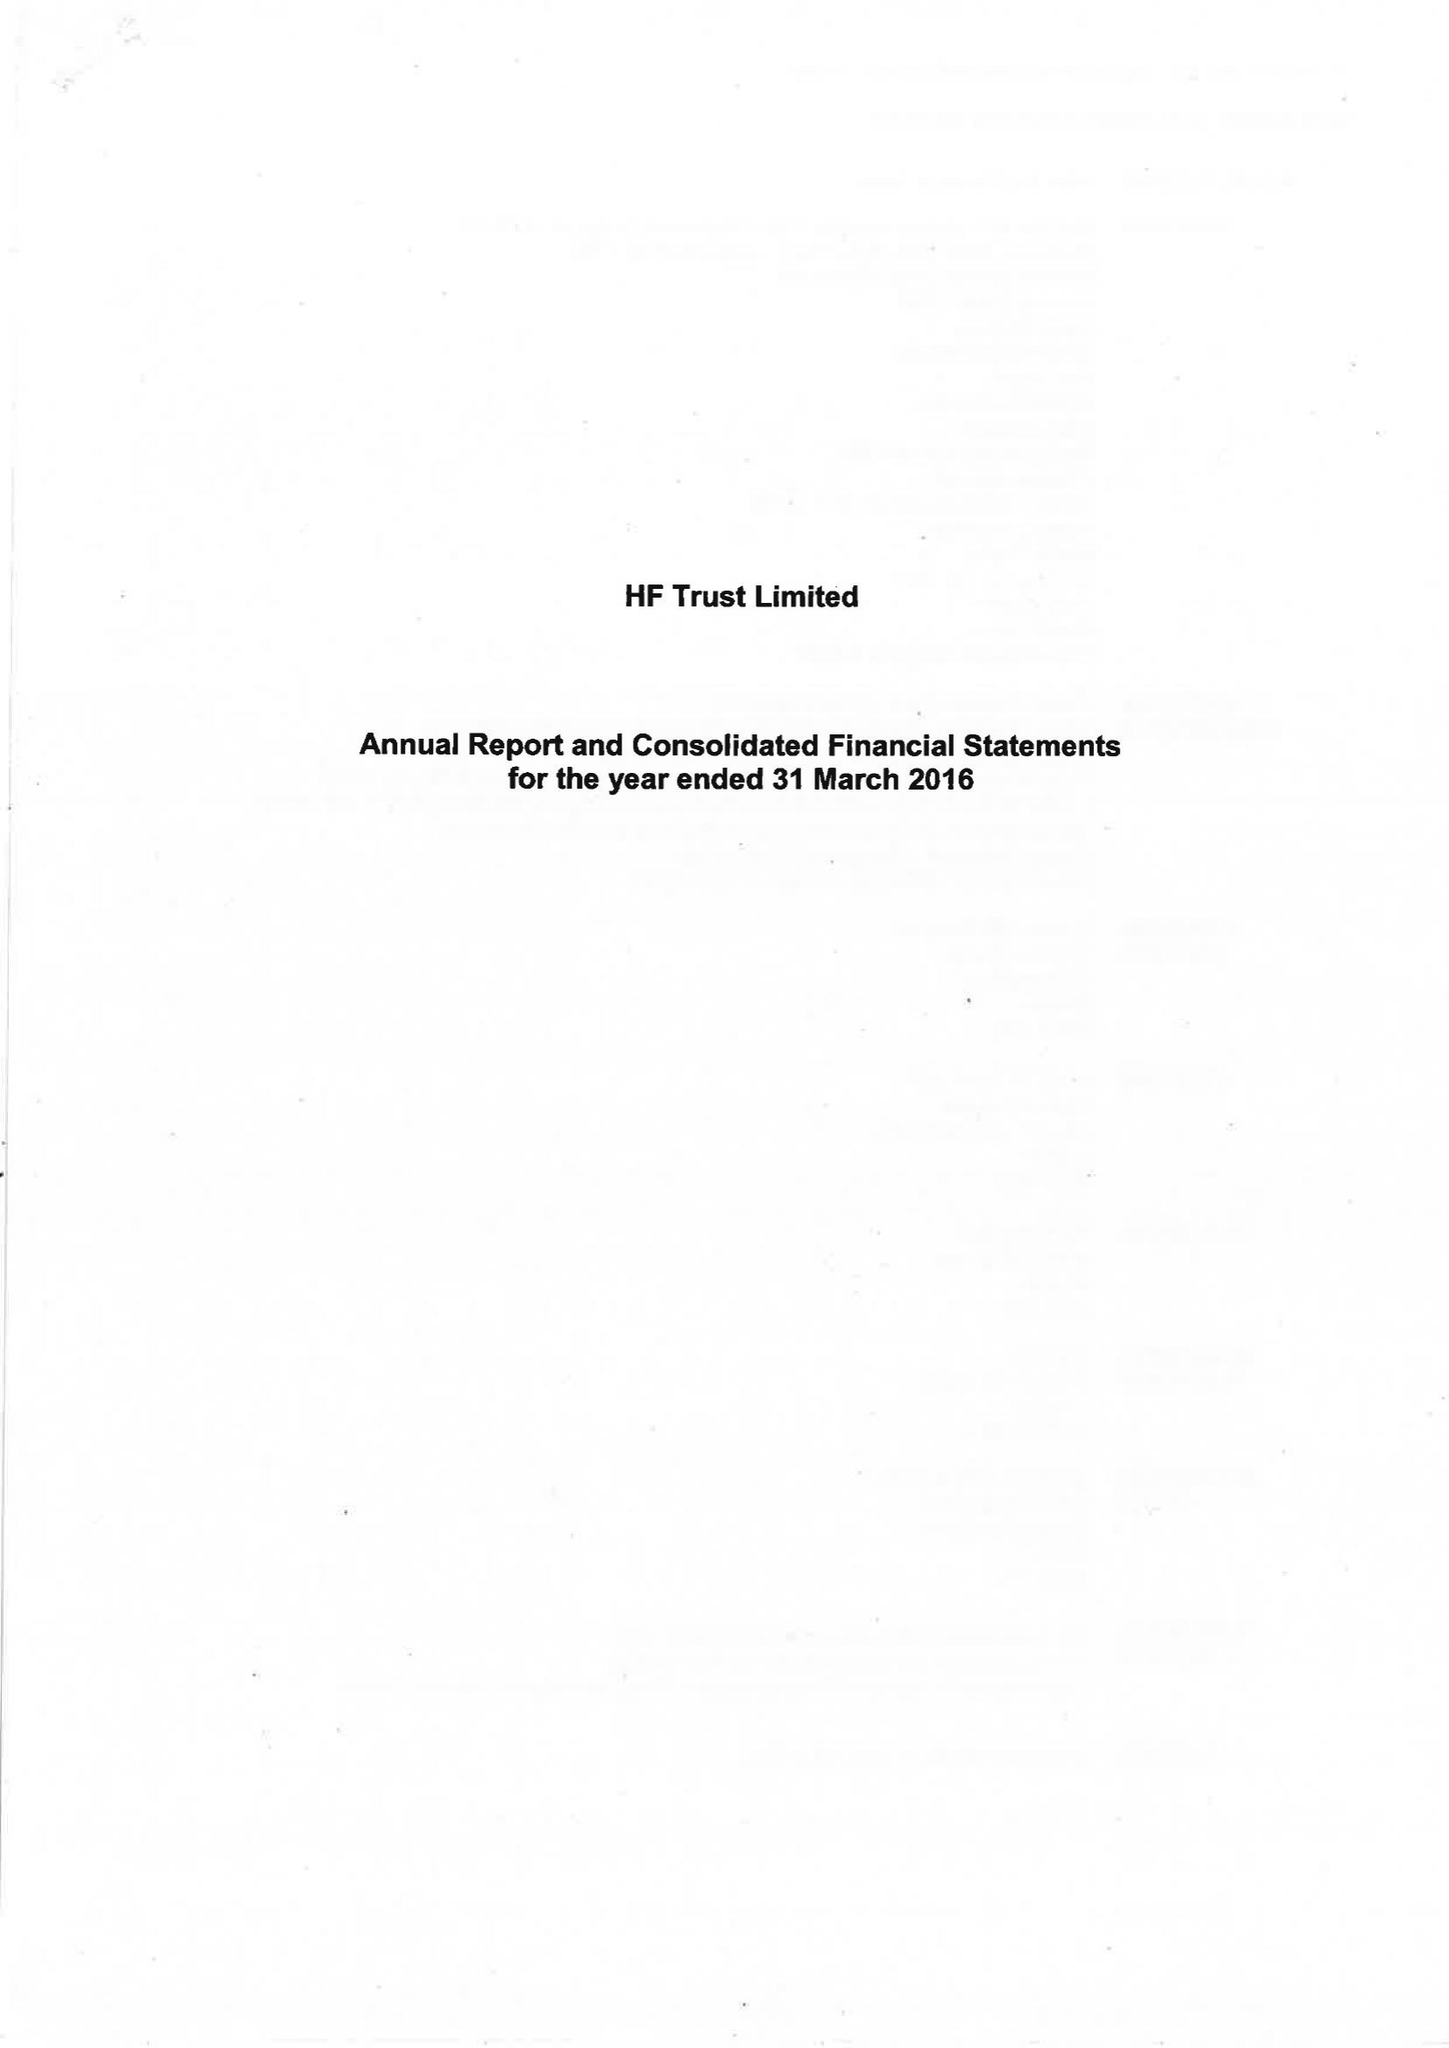What is the value for the income_annually_in_british_pounds?
Answer the question using a single word or phrase. 75064000.00 